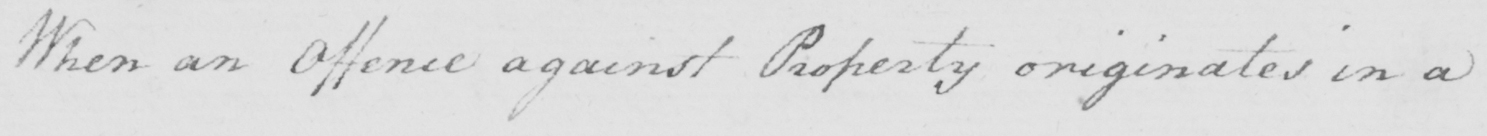Can you tell me what this handwritten text says? When an Offence against Property originates in a 